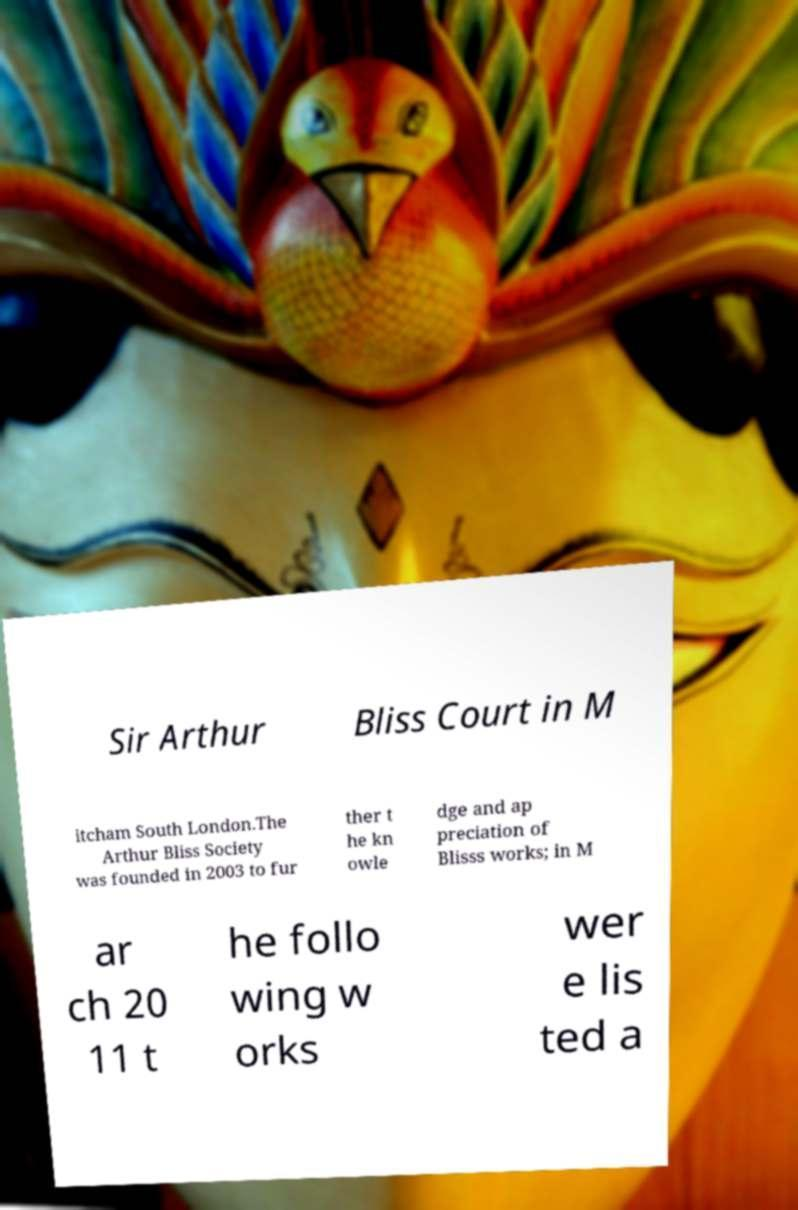Please read and relay the text visible in this image. What does it say? Sir Arthur Bliss Court in M itcham South London.The Arthur Bliss Society was founded in 2003 to fur ther t he kn owle dge and ap preciation of Blisss works; in M ar ch 20 11 t he follo wing w orks wer e lis ted a 